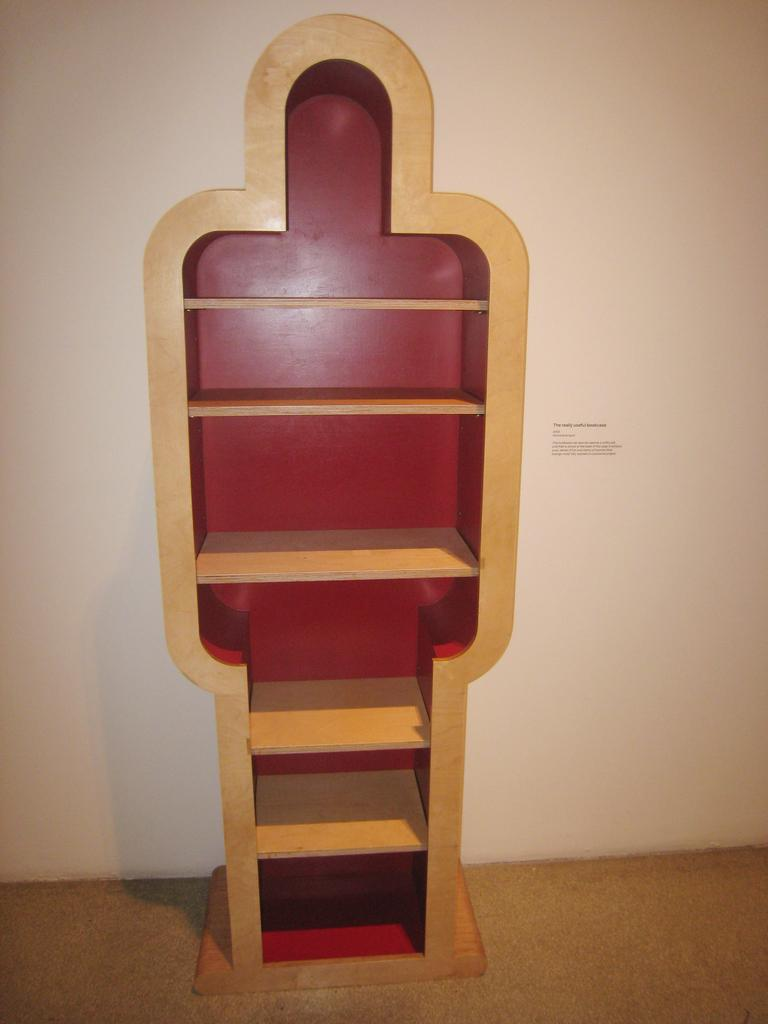What color is the background of the image? The background of the image is white. What type of flooring is visible in the image? There is a wooden floor in the image. What object can be seen on the wooden floor? There is an empty wooden organizer in the image. What type of instrument is being played in the image? There is no instrument being played in the image; it only features an empty wooden organizer. What type of food is being prepared in the image? There is no food preparation visible in the image; it only features an empty wooden organizer. 